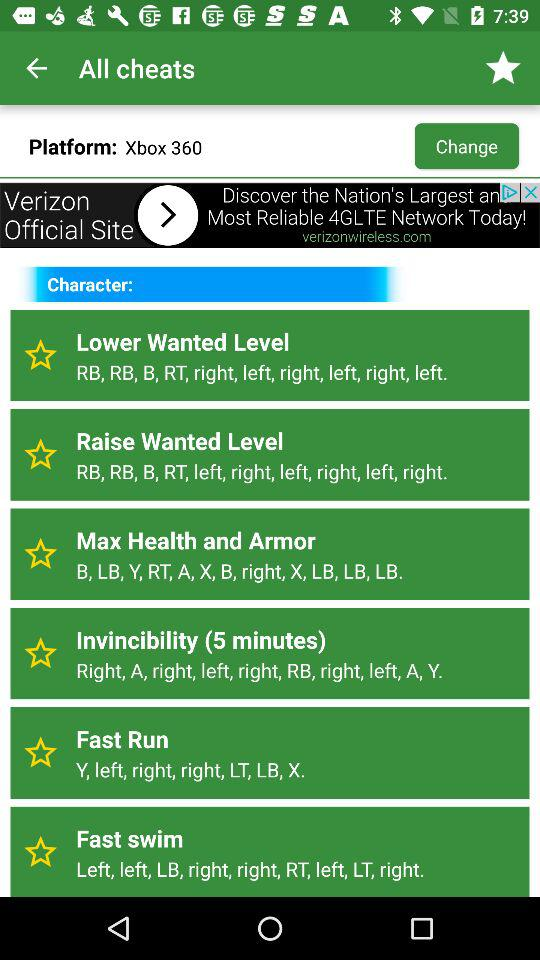What is the selected platform? The selected platform is "Xbox 360". 